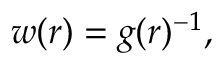Convert formula to latex. <formula><loc_0><loc_0><loc_500><loc_500>w ( r ) = g ( r ) ^ { - 1 } ,</formula> 